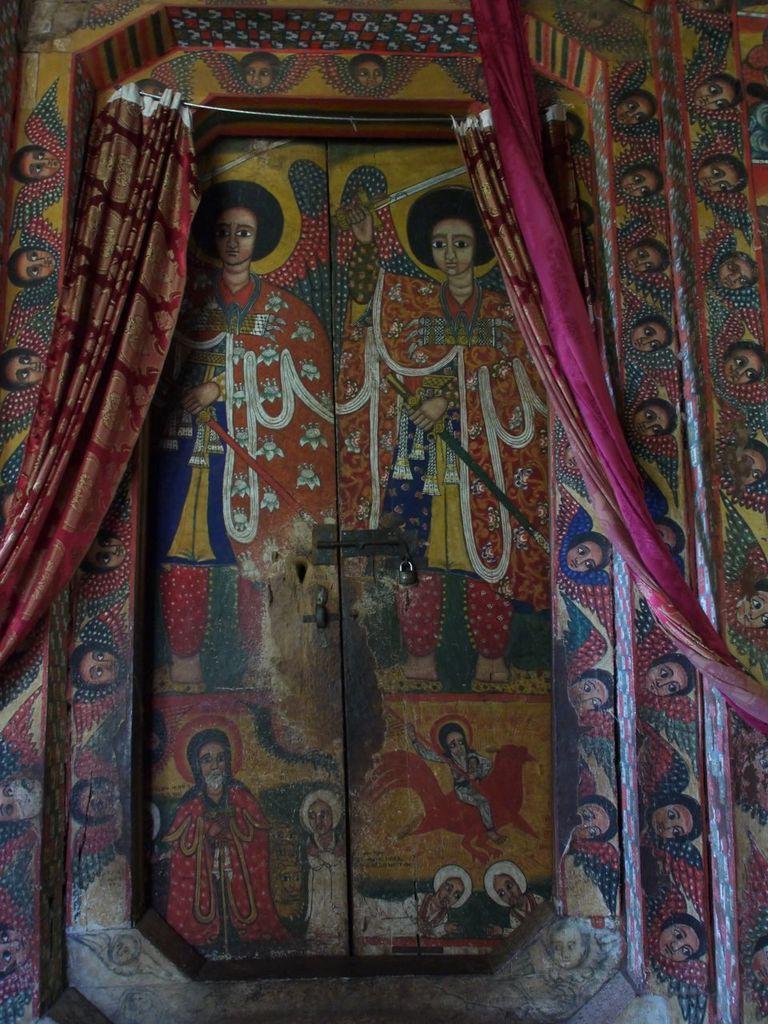In one or two sentences, can you explain what this image depicts? In this picture we can see a wall, doors, here we can see a painting and curtains. 